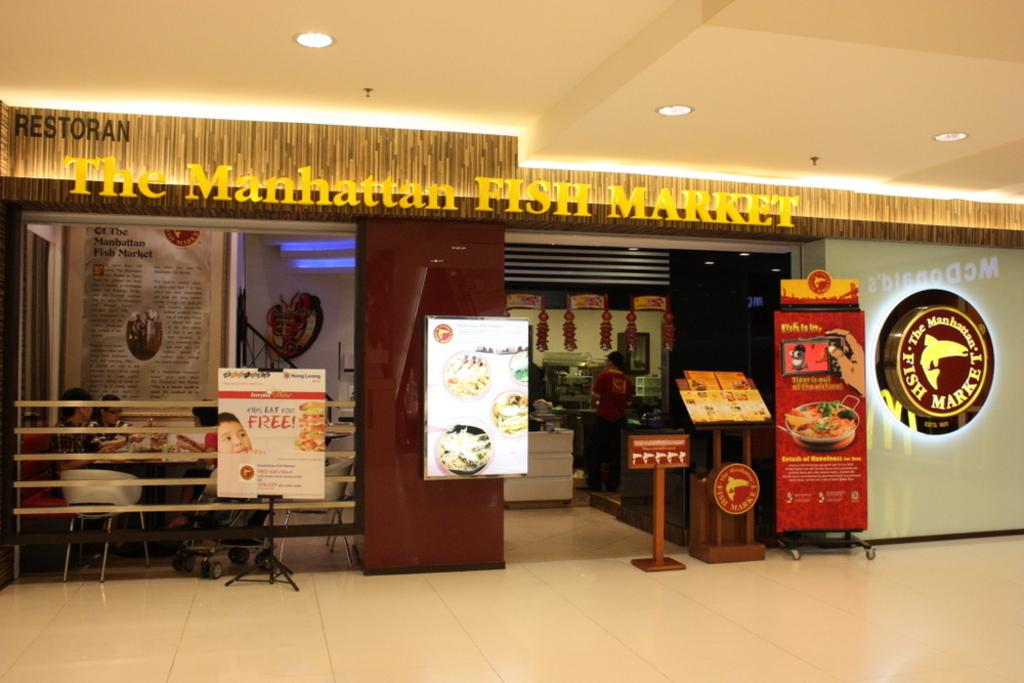<image>
Present a compact description of the photo's key features. The manhattan fish market restaurant with people sitting inside 